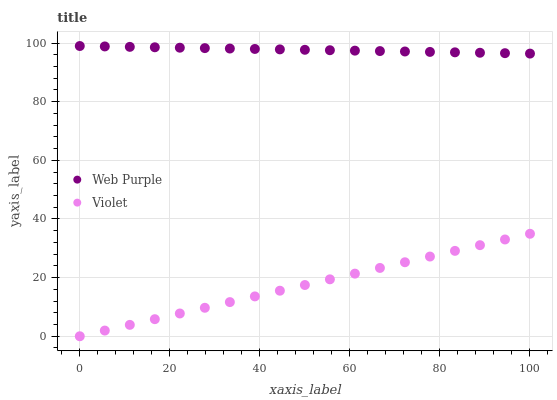Does Violet have the minimum area under the curve?
Answer yes or no. Yes. Does Web Purple have the maximum area under the curve?
Answer yes or no. Yes. Does Violet have the maximum area under the curve?
Answer yes or no. No. Is Violet the smoothest?
Answer yes or no. Yes. Is Web Purple the roughest?
Answer yes or no. Yes. Is Violet the roughest?
Answer yes or no. No. Does Violet have the lowest value?
Answer yes or no. Yes. Does Web Purple have the highest value?
Answer yes or no. Yes. Does Violet have the highest value?
Answer yes or no. No. Is Violet less than Web Purple?
Answer yes or no. Yes. Is Web Purple greater than Violet?
Answer yes or no. Yes. Does Violet intersect Web Purple?
Answer yes or no. No. 